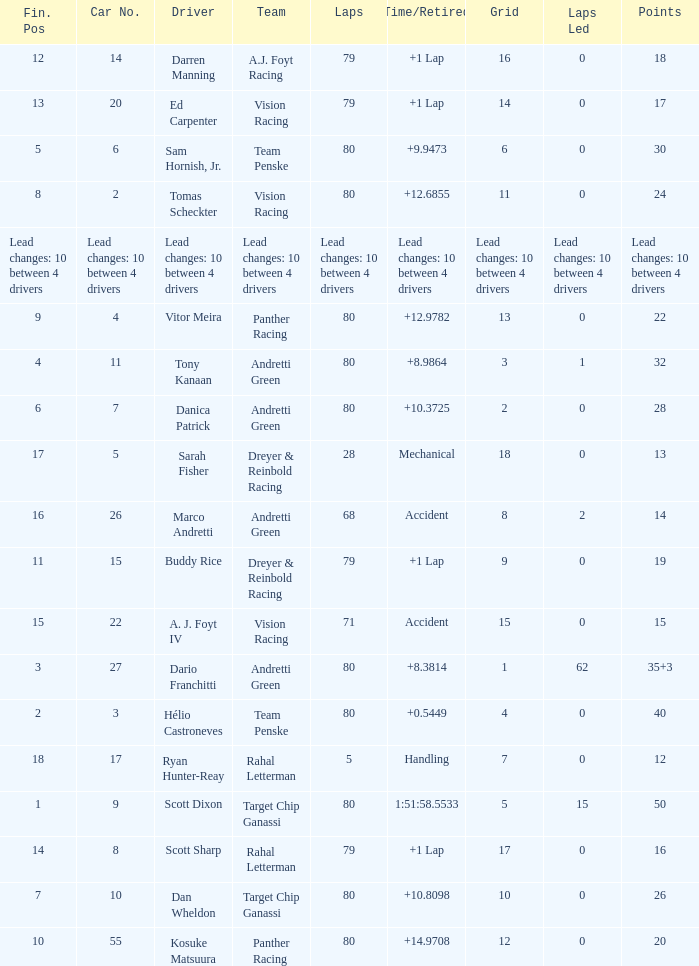How many laps does driver dario franchitti have? 80.0. Write the full table. {'header': ['Fin. Pos', 'Car No.', 'Driver', 'Team', 'Laps', 'Time/Retired', 'Grid', 'Laps Led', 'Points'], 'rows': [['12', '14', 'Darren Manning', 'A.J. Foyt Racing', '79', '+1 Lap', '16', '0', '18'], ['13', '20', 'Ed Carpenter', 'Vision Racing', '79', '+1 Lap', '14', '0', '17'], ['5', '6', 'Sam Hornish, Jr.', 'Team Penske', '80', '+9.9473', '6', '0', '30'], ['8', '2', 'Tomas Scheckter', 'Vision Racing', '80', '+12.6855', '11', '0', '24'], ['Lead changes: 10 between 4 drivers', 'Lead changes: 10 between 4 drivers', 'Lead changes: 10 between 4 drivers', 'Lead changes: 10 between 4 drivers', 'Lead changes: 10 between 4 drivers', 'Lead changes: 10 between 4 drivers', 'Lead changes: 10 between 4 drivers', 'Lead changes: 10 between 4 drivers', 'Lead changes: 10 between 4 drivers'], ['9', '4', 'Vitor Meira', 'Panther Racing', '80', '+12.9782', '13', '0', '22'], ['4', '11', 'Tony Kanaan', 'Andretti Green', '80', '+8.9864', '3', '1', '32'], ['6', '7', 'Danica Patrick', 'Andretti Green', '80', '+10.3725', '2', '0', '28'], ['17', '5', 'Sarah Fisher', 'Dreyer & Reinbold Racing', '28', 'Mechanical', '18', '0', '13'], ['16', '26', 'Marco Andretti', 'Andretti Green', '68', 'Accident', '8', '2', '14'], ['11', '15', 'Buddy Rice', 'Dreyer & Reinbold Racing', '79', '+1 Lap', '9', '0', '19'], ['15', '22', 'A. J. Foyt IV', 'Vision Racing', '71', 'Accident', '15', '0', '15'], ['3', '27', 'Dario Franchitti', 'Andretti Green', '80', '+8.3814', '1', '62', '35+3'], ['2', '3', 'Hélio Castroneves', 'Team Penske', '80', '+0.5449', '4', '0', '40'], ['18', '17', 'Ryan Hunter-Reay', 'Rahal Letterman', '5', 'Handling', '7', '0', '12'], ['1', '9', 'Scott Dixon', 'Target Chip Ganassi', '80', '1:51:58.5533', '5', '15', '50'], ['14', '8', 'Scott Sharp', 'Rahal Letterman', '79', '+1 Lap', '17', '0', '16'], ['7', '10', 'Dan Wheldon', 'Target Chip Ganassi', '80', '+10.8098', '10', '0', '26'], ['10', '55', 'Kosuke Matsuura', 'Panther Racing', '80', '+14.9708', '12', '0', '20']]} 